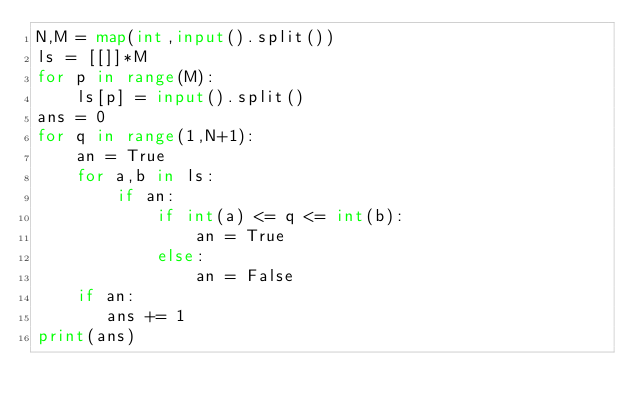Convert code to text. <code><loc_0><loc_0><loc_500><loc_500><_Python_>N,M = map(int,input().split())
ls = [[]]*M
for p in range(M):
    ls[p] = input().split()
ans = 0
for q in range(1,N+1):
    an = True
    for a,b in ls:
        if an:
            if int(a) <= q <= int(b):
                an = True
            else:
                an = False
    if an:
       ans += 1
print(ans)</code> 